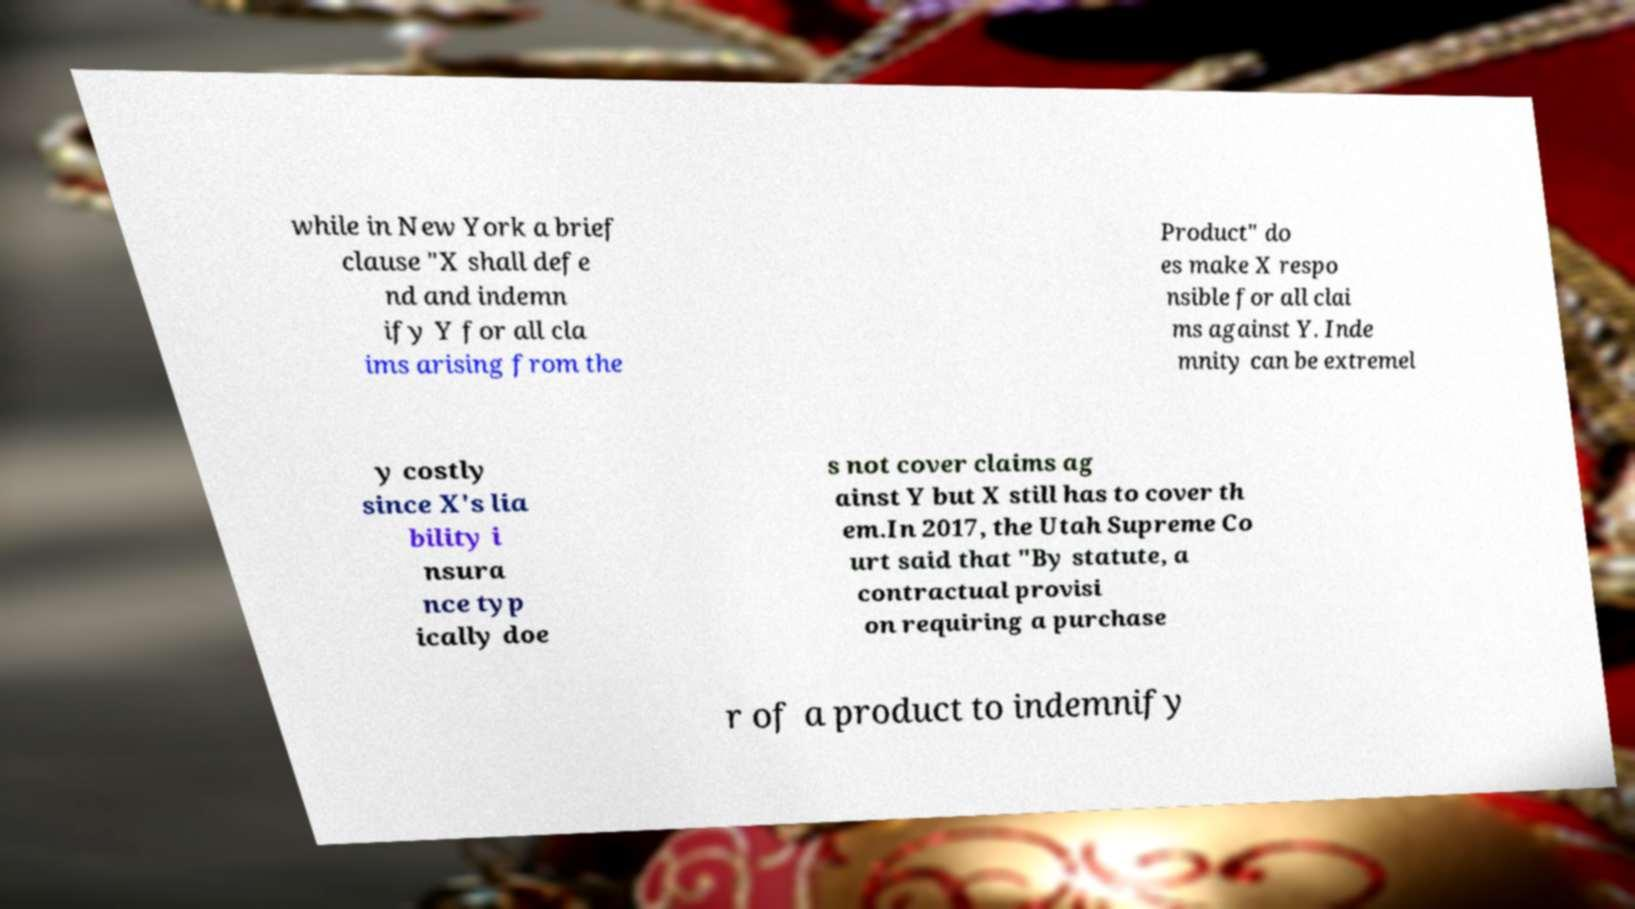I need the written content from this picture converted into text. Can you do that? while in New York a brief clause "X shall defe nd and indemn ify Y for all cla ims arising from the Product" do es make X respo nsible for all clai ms against Y. Inde mnity can be extremel y costly since X's lia bility i nsura nce typ ically doe s not cover claims ag ainst Y but X still has to cover th em.In 2017, the Utah Supreme Co urt said that "By statute, a contractual provisi on requiring a purchase r of a product to indemnify 